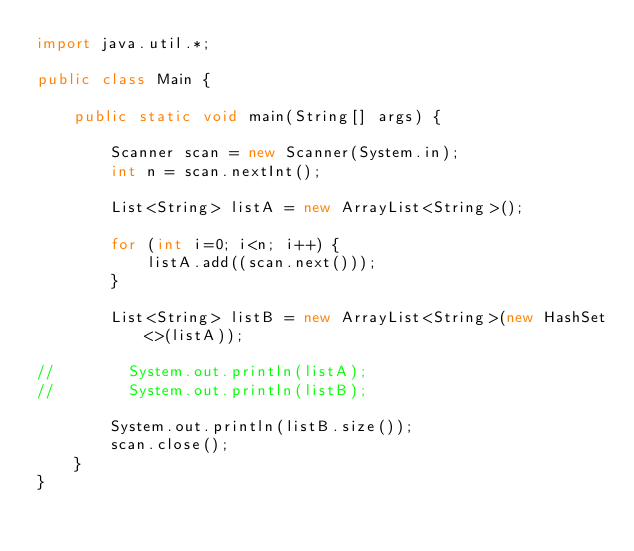Convert code to text. <code><loc_0><loc_0><loc_500><loc_500><_Java_>import java.util.*;

public class Main {

    public static void main(String[] args) {

        Scanner scan = new Scanner(System.in);
        int n = scan.nextInt();

		List<String> listA = new ArrayList<String>(); 
        
        for (int i=0; i<n; i++) {
			listA.add((scan.next()));
        }

        List<String> listB = new ArrayList<String>(new HashSet<>(listA));

//        System.out.println(listA);
//        System.out.println(listB);

        System.out.println(listB.size());
	    scan.close();	
    }
}</code> 